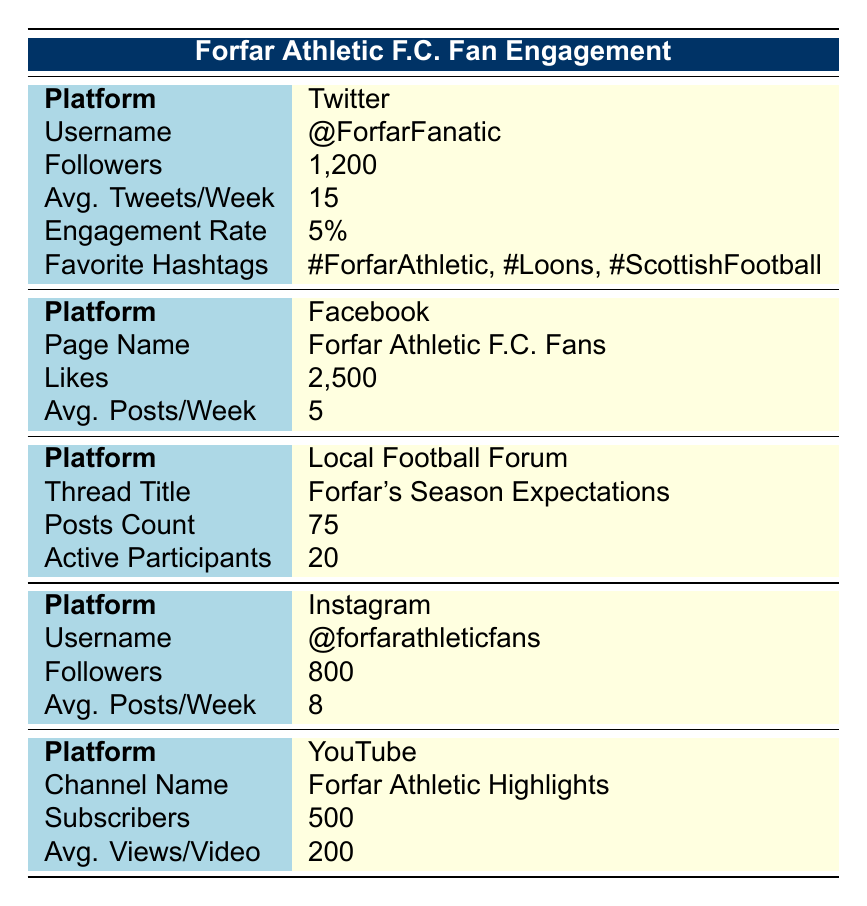What is the average number of posts per week for the Facebook platform? The table indicates that the average number of posts per week for Facebook is recorded as 5.
Answer: 5 What is the engagement rate for the Twitter account? The engagement rate for the Twitter account (@ForfarFanatic) is directly provided in the table as 5%.
Answer: 5% Which platform has the highest number of followers? By comparing the follower counts listed for Twitter (1200), Facebook (2500), Instagram (800), and YouTube (500), Facebook has the highest followers at 2500.
Answer: Facebook Is the Twitter account more active than the Instagram account based on average posts per week? The Twitter account averages 15 tweets per week while the Instagram account averages 8 posts per week. Therefore, the Twitter account is more active.
Answer: Yes What is the total number of likes from the two Social Media platforms, Twitter and Instagram? The table lists 1200 followers for Twitter and 500 subscribers for YouTube. This sum is 1200 + 2500 = 3700.
Answer: 3700 Which platform has the most recent post date? The most recent post on Twitter is dated 2023-10-01, which is later than the other listed dates for Facebook (2023-09-15) and others. Thus, Twitter has the most recent post.
Answer: Twitter Among the platforms listed, which has the least number of active participants in its forum? The Local Football Forum mentions 20 active participants, which is less than the interaction levels on platforms like Facebook. Therefore, Local Football Forum has the least active participants.
Answer: Local Football Forum What percentage of Facebook poll respondents believe Forfar will finish in the top half? The poll results on Facebook indicate that 40 out of 100 respondents believe they will finish in the top half, so the percentage is (40/100) * 100% = 40%.
Answer: 40% What was the content of the most engaging post on Facebook? According to the table, the most engaging Facebook post content was about excitement for an upcoming derby, asking fans to get behind the team.
Answer: Who's excited for the derby coming up? Let's get behind the team! 